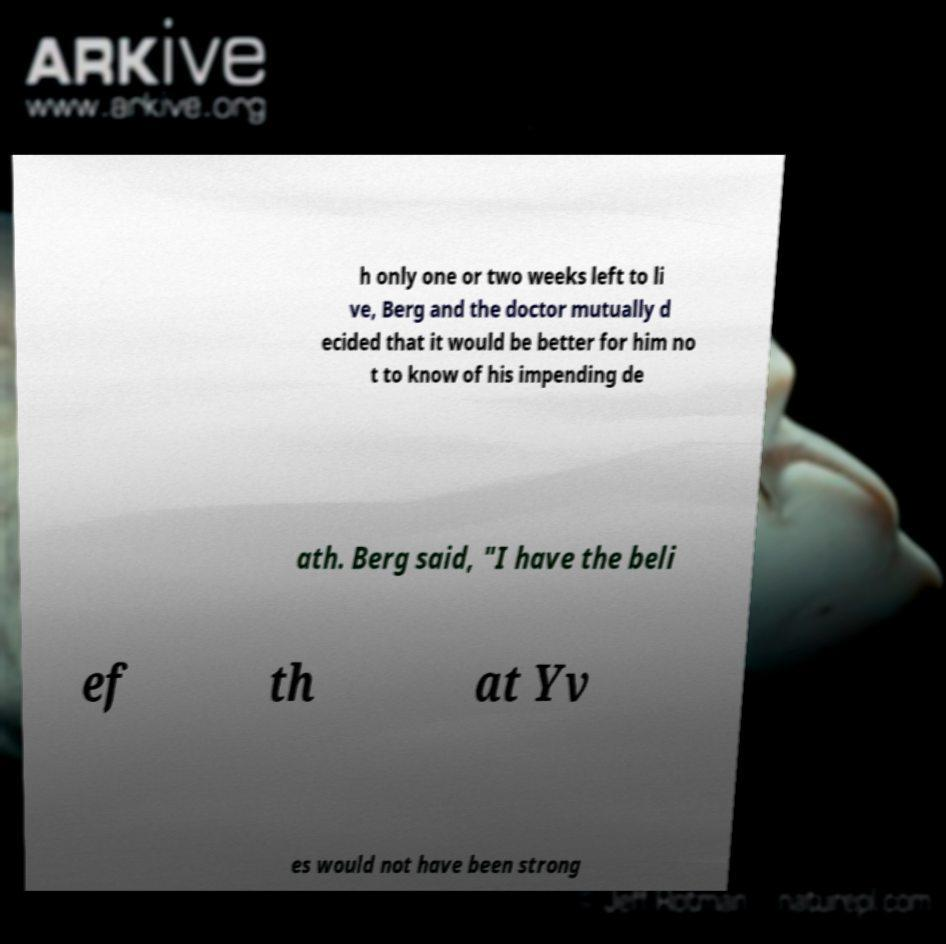Could you extract and type out the text from this image? h only one or two weeks left to li ve, Berg and the doctor mutually d ecided that it would be better for him no t to know of his impending de ath. Berg said, "I have the beli ef th at Yv es would not have been strong 